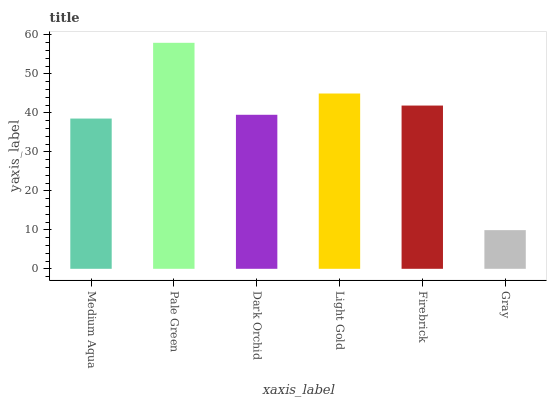Is Gray the minimum?
Answer yes or no. Yes. Is Pale Green the maximum?
Answer yes or no. Yes. Is Dark Orchid the minimum?
Answer yes or no. No. Is Dark Orchid the maximum?
Answer yes or no. No. Is Pale Green greater than Dark Orchid?
Answer yes or no. Yes. Is Dark Orchid less than Pale Green?
Answer yes or no. Yes. Is Dark Orchid greater than Pale Green?
Answer yes or no. No. Is Pale Green less than Dark Orchid?
Answer yes or no. No. Is Firebrick the high median?
Answer yes or no. Yes. Is Dark Orchid the low median?
Answer yes or no. Yes. Is Pale Green the high median?
Answer yes or no. No. Is Medium Aqua the low median?
Answer yes or no. No. 